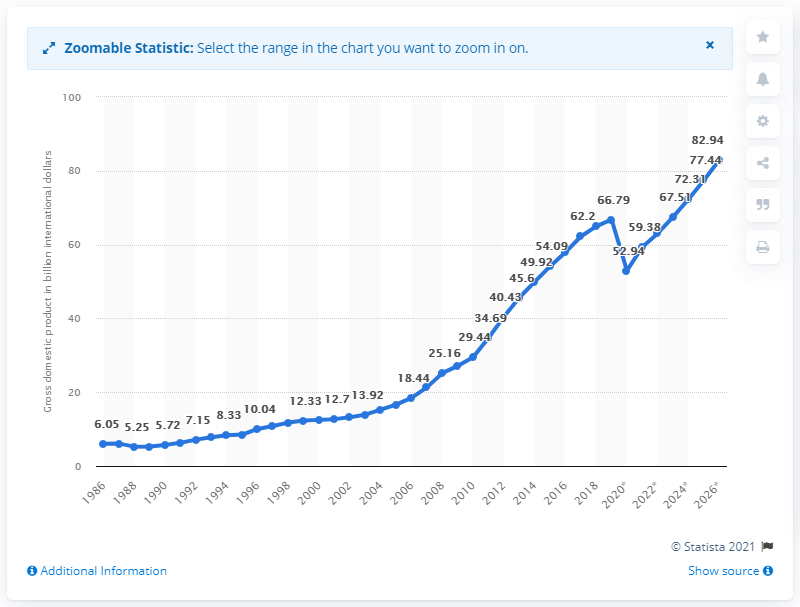Indicate a few pertinent items in this graphic. In 2019, the Gross Domestic Product (GDP) of Panama was 66.79. 